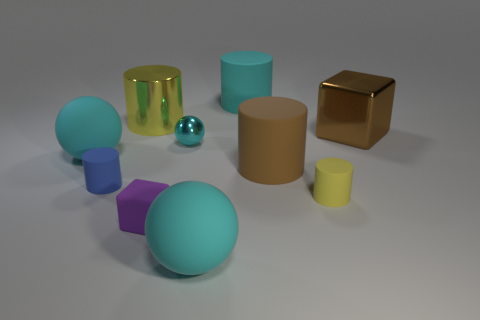There is a cube that is the same size as the brown matte cylinder; what material is it?
Your response must be concise. Metal. What number of other things are the same material as the large yellow cylinder?
Your response must be concise. 2. There is a big metallic object that is in front of the yellow cylinder behind the blue rubber thing; what is its shape?
Your response must be concise. Cube. What number of things are small yellow objects or big things that are in front of the big yellow thing?
Keep it short and to the point. 5. How many other things are the same color as the tiny metal ball?
Keep it short and to the point. 3. What number of cyan objects are matte balls or shiny cubes?
Your answer should be compact. 2. There is a large matte ball that is on the right side of the cyan matte ball that is left of the tiny purple object; are there any big cyan objects to the left of it?
Ensure brevity in your answer.  Yes. Do the small metal ball and the large shiny cylinder have the same color?
Ensure brevity in your answer.  No. There is a tiny thing that is behind the large cyan matte sphere that is on the left side of the tiny blue rubber cylinder; what color is it?
Your answer should be compact. Cyan. How many tiny things are either brown cylinders or purple cubes?
Give a very brief answer. 1. 